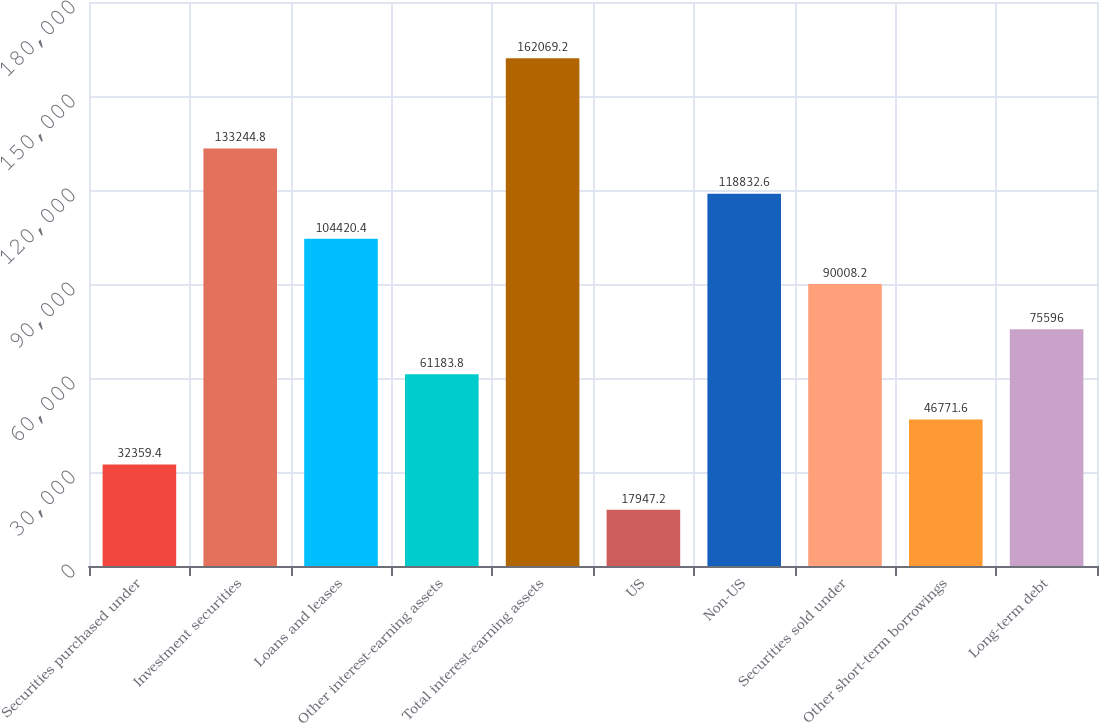Convert chart to OTSL. <chart><loc_0><loc_0><loc_500><loc_500><bar_chart><fcel>Securities purchased under<fcel>Investment securities<fcel>Loans and leases<fcel>Other interest-earning assets<fcel>Total interest-earning assets<fcel>US<fcel>Non-US<fcel>Securities sold under<fcel>Other short-term borrowings<fcel>Long-term debt<nl><fcel>32359.4<fcel>133245<fcel>104420<fcel>61183.8<fcel>162069<fcel>17947.2<fcel>118833<fcel>90008.2<fcel>46771.6<fcel>75596<nl></chart> 